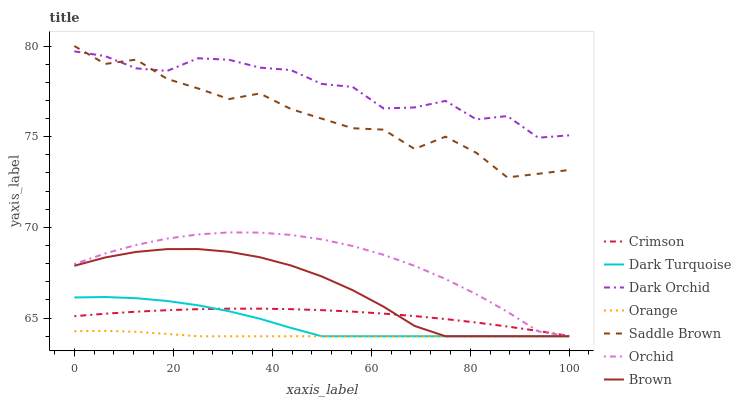Does Orange have the minimum area under the curve?
Answer yes or no. Yes. Does Dark Orchid have the maximum area under the curve?
Answer yes or no. Yes. Does Dark Turquoise have the minimum area under the curve?
Answer yes or no. No. Does Dark Turquoise have the maximum area under the curve?
Answer yes or no. No. Is Orange the smoothest?
Answer yes or no. Yes. Is Dark Orchid the roughest?
Answer yes or no. Yes. Is Dark Turquoise the smoothest?
Answer yes or no. No. Is Dark Turquoise the roughest?
Answer yes or no. No. Does Brown have the lowest value?
Answer yes or no. Yes. Does Dark Orchid have the lowest value?
Answer yes or no. No. Does Saddle Brown have the highest value?
Answer yes or no. Yes. Does Dark Turquoise have the highest value?
Answer yes or no. No. Is Brown less than Saddle Brown?
Answer yes or no. Yes. Is Saddle Brown greater than Orange?
Answer yes or no. Yes. Does Brown intersect Orange?
Answer yes or no. Yes. Is Brown less than Orange?
Answer yes or no. No. Is Brown greater than Orange?
Answer yes or no. No. Does Brown intersect Saddle Brown?
Answer yes or no. No. 